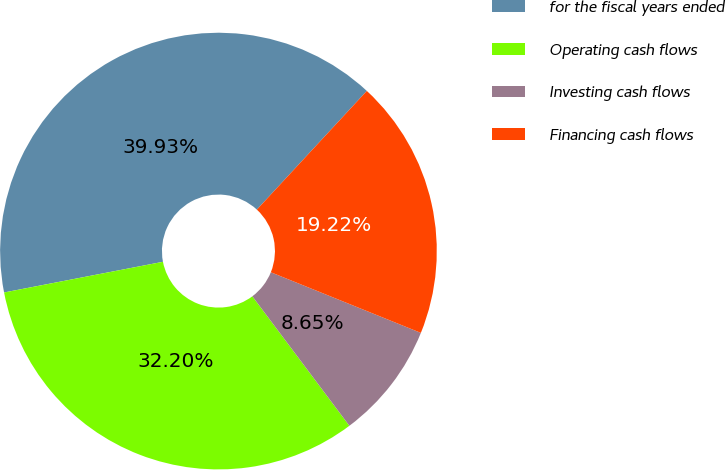Convert chart. <chart><loc_0><loc_0><loc_500><loc_500><pie_chart><fcel>for the fiscal years ended<fcel>Operating cash flows<fcel>Investing cash flows<fcel>Financing cash flows<nl><fcel>39.93%<fcel>32.2%<fcel>8.65%<fcel>19.22%<nl></chart> 